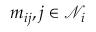<formula> <loc_0><loc_0><loc_500><loc_500>{ m _ { i j } , j \in \mathcal { N } _ { i } }</formula> 